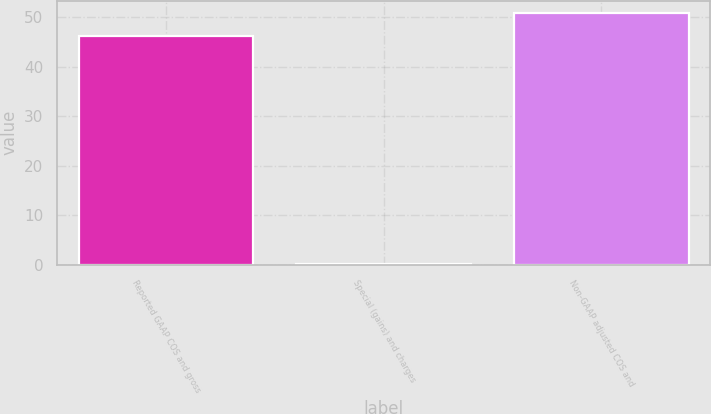Convert chart to OTSL. <chart><loc_0><loc_0><loc_500><loc_500><bar_chart><fcel>Reported GAAP COS and gross<fcel>Special (gains) and charges<fcel>Non-GAAP adjusted COS and<nl><fcel>46.2<fcel>0.1<fcel>50.82<nl></chart> 